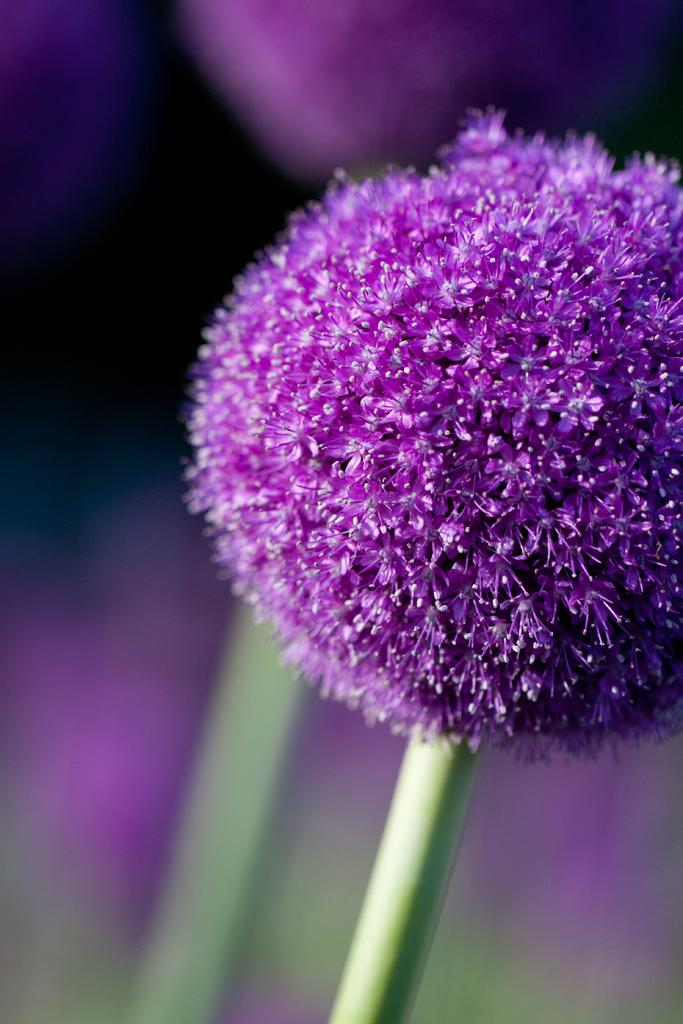What is the main subject of the image? There is a flower in the image. What color is the flower? The flower is purple in color. Can you describe the background of the image? The background of the image is blurred. Can you tell me how many feathers are attached to the flower in the image? There are no feathers present in the image; it features a purple flower with a blurred background. What type of credit can be seen on the flower in the image? There is no credit present on the flower in the image; it is a simple photograph of a purple flower with a blurred background. 